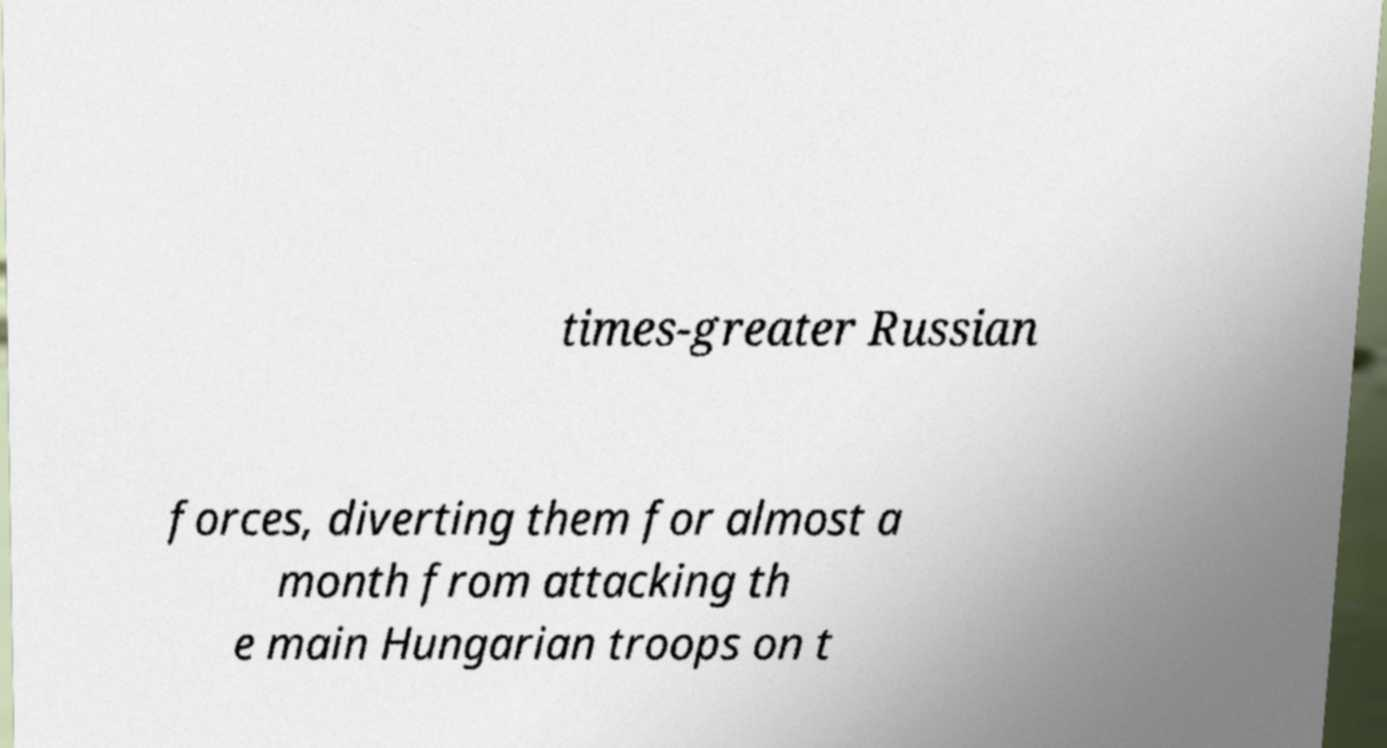I need the written content from this picture converted into text. Can you do that? times-greater Russian forces, diverting them for almost a month from attacking th e main Hungarian troops on t 